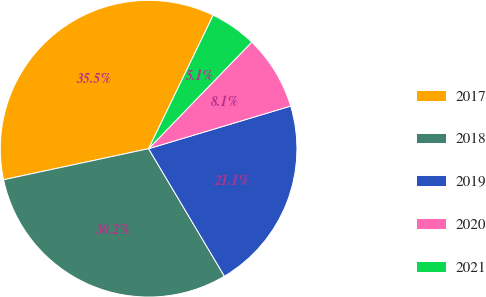Convert chart to OTSL. <chart><loc_0><loc_0><loc_500><loc_500><pie_chart><fcel>2017<fcel>2018<fcel>2019<fcel>2020<fcel>2021<nl><fcel>35.52%<fcel>30.18%<fcel>21.1%<fcel>8.12%<fcel>5.07%<nl></chart> 